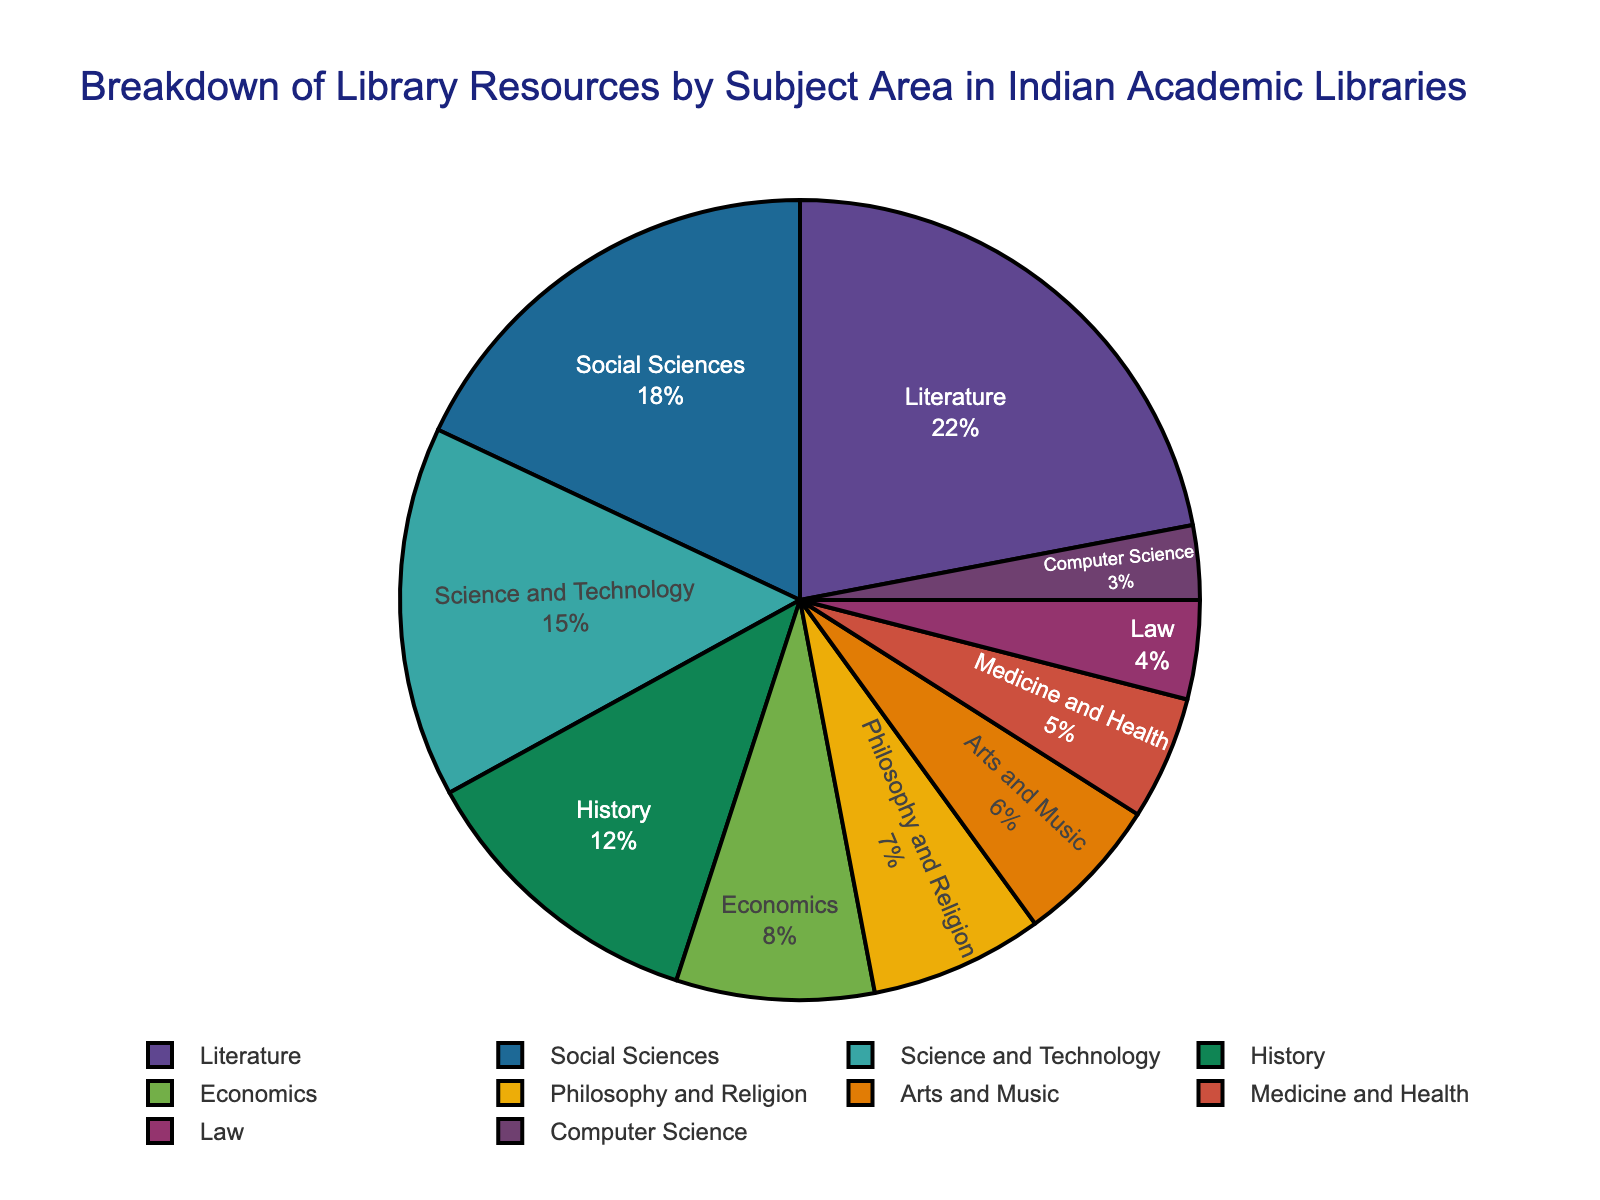What percentage of library resources is allocated to Literature? To find the percentage allocated to Literature, simply refer to the segment labeled "Literature" on the pie chart.
Answer: 22% Which subject area has the least percentage of library resources? Check the pie chart for the smallest segment which is labeled with its respective subject.
Answer: Computer Science Is the percentage of resources allocated to Economics more or less than that for Social Sciences? Compare the pie chart segments labeled "Economics" and "Social Sciences" by looking at their respective percentages.
Answer: Less What is the total percentage of library resources allocated to Science and Technology, Medicine and Health, and Computer Science? Sum the individual percentages of Science and Technology (15%), Medicine and Health (5%), and Computer Science (3%) from the pie chart: 15% + 5% + 3% = 23%
Answer: 23% Which subject has a higher percentage, Arts and Music or Philosophy and Religion? Compare the segments for Arts and Music and Philosophy and Religion by looking at their respective percentages.
Answer: Philosophy and Religion What is the difference in percentage between History and Law? Subtract the percentage for Law (4%) from the percentage for History (12%): 12% - 4% = 8%
Answer: 8% What subject areas together make up more than 50% of the library resources? Identify segments whose combined percentages exceed 50%. Literature (22%), Social Sciences (18%), and Science and Technology (15%) together make 55% (22% + 18% + 15% = 55%).
Answer: Literature, Social Sciences, and Science and Technology Compare the percentage of resources allocated to Science and Technology with Medicine and Health. How many times is Science and Technology larger? Divide the percentage of Science and Technology (15%) by Medicine and Health (5%): 15 / 5 = 3 times.
Answer: 3 times 